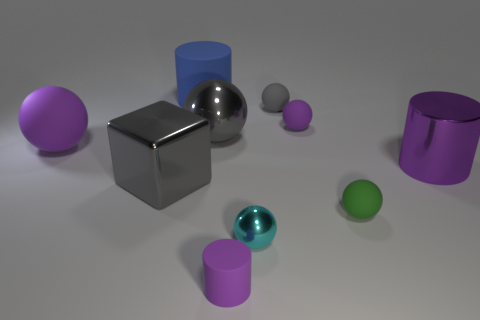Subtract all purple cylinders. How many cylinders are left? 1 Subtract all gray cylinders. How many gray balls are left? 2 Subtract all green balls. How many balls are left? 5 Subtract all blocks. How many objects are left? 9 Subtract all green cylinders. Subtract all green cubes. How many cylinders are left? 3 Add 1 tiny red things. How many tiny red things exist? 1 Subtract 0 yellow spheres. How many objects are left? 10 Subtract all large blue objects. Subtract all tiny cyan metallic things. How many objects are left? 8 Add 5 gray metal cubes. How many gray metal cubes are left? 6 